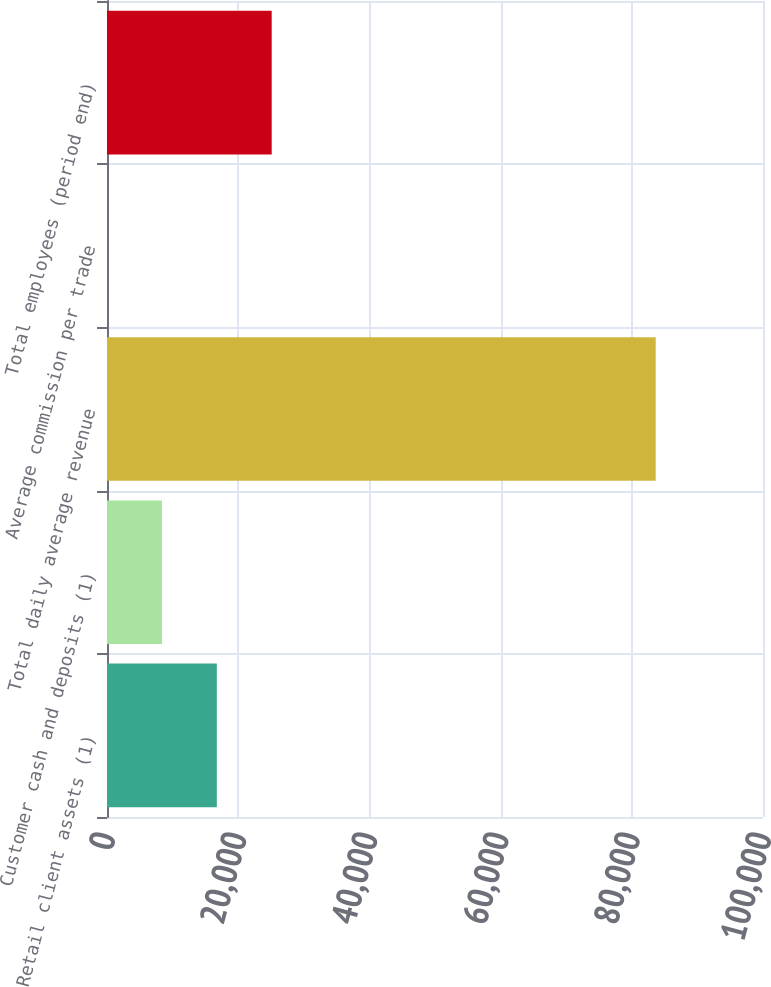<chart> <loc_0><loc_0><loc_500><loc_500><bar_chart><fcel>Retail client assets (1)<fcel>Customer cash and deposits (1)<fcel>Total daily average revenue<fcel>Average commission per trade<fcel>Total employees (period end)<nl><fcel>16741.1<fcel>8378.37<fcel>83643<fcel>15.63<fcel>25103.8<nl></chart> 